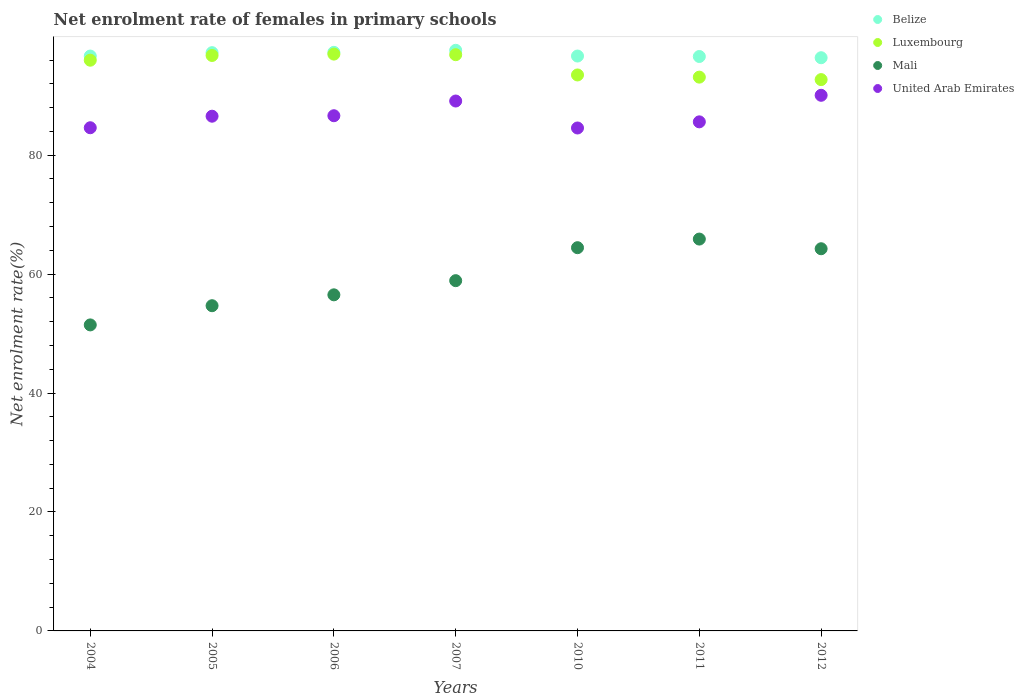How many different coloured dotlines are there?
Offer a very short reply. 4. Is the number of dotlines equal to the number of legend labels?
Your answer should be compact. Yes. What is the net enrolment rate of females in primary schools in Belize in 2006?
Your answer should be very brief. 97.29. Across all years, what is the maximum net enrolment rate of females in primary schools in Luxembourg?
Your response must be concise. 97. Across all years, what is the minimum net enrolment rate of females in primary schools in Luxembourg?
Make the answer very short. 92.71. In which year was the net enrolment rate of females in primary schools in Belize minimum?
Make the answer very short. 2012. What is the total net enrolment rate of females in primary schools in United Arab Emirates in the graph?
Your answer should be very brief. 607.16. What is the difference between the net enrolment rate of females in primary schools in Mali in 2004 and that in 2007?
Keep it short and to the point. -7.44. What is the difference between the net enrolment rate of females in primary schools in Luxembourg in 2012 and the net enrolment rate of females in primary schools in Belize in 2007?
Make the answer very short. -4.93. What is the average net enrolment rate of females in primary schools in Belize per year?
Your answer should be compact. 96.93. In the year 2007, what is the difference between the net enrolment rate of females in primary schools in Belize and net enrolment rate of females in primary schools in United Arab Emirates?
Your response must be concise. 8.53. In how many years, is the net enrolment rate of females in primary schools in Belize greater than 40 %?
Provide a short and direct response. 7. What is the ratio of the net enrolment rate of females in primary schools in Belize in 2006 to that in 2010?
Provide a succinct answer. 1.01. Is the net enrolment rate of females in primary schools in Belize in 2010 less than that in 2011?
Offer a very short reply. No. Is the difference between the net enrolment rate of females in primary schools in Belize in 2010 and 2011 greater than the difference between the net enrolment rate of females in primary schools in United Arab Emirates in 2010 and 2011?
Provide a succinct answer. Yes. What is the difference between the highest and the second highest net enrolment rate of females in primary schools in Mali?
Your response must be concise. 1.45. What is the difference between the highest and the lowest net enrolment rate of females in primary schools in Belize?
Offer a terse response. 1.25. Is it the case that in every year, the sum of the net enrolment rate of females in primary schools in Mali and net enrolment rate of females in primary schools in Belize  is greater than the sum of net enrolment rate of females in primary schools in United Arab Emirates and net enrolment rate of females in primary schools in Luxembourg?
Offer a very short reply. No. Is it the case that in every year, the sum of the net enrolment rate of females in primary schools in Mali and net enrolment rate of females in primary schools in Belize  is greater than the net enrolment rate of females in primary schools in Luxembourg?
Your answer should be very brief. Yes. Does the net enrolment rate of females in primary schools in Mali monotonically increase over the years?
Your answer should be compact. No. How many dotlines are there?
Provide a short and direct response. 4. How many years are there in the graph?
Ensure brevity in your answer.  7. What is the difference between two consecutive major ticks on the Y-axis?
Provide a succinct answer. 20. Does the graph contain any zero values?
Offer a terse response. No. How many legend labels are there?
Make the answer very short. 4. What is the title of the graph?
Your response must be concise. Net enrolment rate of females in primary schools. What is the label or title of the Y-axis?
Offer a very short reply. Net enrolment rate(%). What is the Net enrolment rate(%) of Belize in 2004?
Your answer should be very brief. 96.67. What is the Net enrolment rate(%) of Luxembourg in 2004?
Your answer should be very brief. 95.97. What is the Net enrolment rate(%) of Mali in 2004?
Provide a short and direct response. 51.46. What is the Net enrolment rate(%) of United Arab Emirates in 2004?
Your answer should be compact. 84.61. What is the Net enrolment rate(%) in Belize in 2005?
Your response must be concise. 97.24. What is the Net enrolment rate(%) of Luxembourg in 2005?
Your response must be concise. 96.77. What is the Net enrolment rate(%) of Mali in 2005?
Your answer should be very brief. 54.69. What is the Net enrolment rate(%) of United Arab Emirates in 2005?
Give a very brief answer. 86.55. What is the Net enrolment rate(%) of Belize in 2006?
Ensure brevity in your answer.  97.29. What is the Net enrolment rate(%) of Luxembourg in 2006?
Your answer should be very brief. 97. What is the Net enrolment rate(%) of Mali in 2006?
Offer a very short reply. 56.52. What is the Net enrolment rate(%) in United Arab Emirates in 2006?
Keep it short and to the point. 86.63. What is the Net enrolment rate(%) of Belize in 2007?
Offer a terse response. 97.64. What is the Net enrolment rate(%) in Luxembourg in 2007?
Ensure brevity in your answer.  96.9. What is the Net enrolment rate(%) of Mali in 2007?
Provide a short and direct response. 58.9. What is the Net enrolment rate(%) of United Arab Emirates in 2007?
Keep it short and to the point. 89.11. What is the Net enrolment rate(%) in Belize in 2010?
Your response must be concise. 96.67. What is the Net enrolment rate(%) of Luxembourg in 2010?
Give a very brief answer. 93.49. What is the Net enrolment rate(%) in Mali in 2010?
Keep it short and to the point. 64.44. What is the Net enrolment rate(%) of United Arab Emirates in 2010?
Make the answer very short. 84.57. What is the Net enrolment rate(%) of Belize in 2011?
Offer a terse response. 96.59. What is the Net enrolment rate(%) in Luxembourg in 2011?
Your response must be concise. 93.12. What is the Net enrolment rate(%) of Mali in 2011?
Your answer should be compact. 65.89. What is the Net enrolment rate(%) in United Arab Emirates in 2011?
Offer a terse response. 85.6. What is the Net enrolment rate(%) of Belize in 2012?
Ensure brevity in your answer.  96.39. What is the Net enrolment rate(%) in Luxembourg in 2012?
Ensure brevity in your answer.  92.71. What is the Net enrolment rate(%) in Mali in 2012?
Your response must be concise. 64.27. What is the Net enrolment rate(%) of United Arab Emirates in 2012?
Keep it short and to the point. 90.07. Across all years, what is the maximum Net enrolment rate(%) of Belize?
Ensure brevity in your answer.  97.64. Across all years, what is the maximum Net enrolment rate(%) of Luxembourg?
Your answer should be very brief. 97. Across all years, what is the maximum Net enrolment rate(%) in Mali?
Make the answer very short. 65.89. Across all years, what is the maximum Net enrolment rate(%) in United Arab Emirates?
Give a very brief answer. 90.07. Across all years, what is the minimum Net enrolment rate(%) of Belize?
Offer a terse response. 96.39. Across all years, what is the minimum Net enrolment rate(%) of Luxembourg?
Your answer should be very brief. 92.71. Across all years, what is the minimum Net enrolment rate(%) in Mali?
Make the answer very short. 51.46. Across all years, what is the minimum Net enrolment rate(%) in United Arab Emirates?
Provide a short and direct response. 84.57. What is the total Net enrolment rate(%) in Belize in the graph?
Your answer should be very brief. 678.49. What is the total Net enrolment rate(%) of Luxembourg in the graph?
Your answer should be very brief. 665.96. What is the total Net enrolment rate(%) of Mali in the graph?
Keep it short and to the point. 416.17. What is the total Net enrolment rate(%) in United Arab Emirates in the graph?
Your answer should be compact. 607.16. What is the difference between the Net enrolment rate(%) of Belize in 2004 and that in 2005?
Keep it short and to the point. -0.57. What is the difference between the Net enrolment rate(%) of Luxembourg in 2004 and that in 2005?
Keep it short and to the point. -0.79. What is the difference between the Net enrolment rate(%) in Mali in 2004 and that in 2005?
Ensure brevity in your answer.  -3.23. What is the difference between the Net enrolment rate(%) in United Arab Emirates in 2004 and that in 2005?
Keep it short and to the point. -1.94. What is the difference between the Net enrolment rate(%) of Belize in 2004 and that in 2006?
Ensure brevity in your answer.  -0.62. What is the difference between the Net enrolment rate(%) in Luxembourg in 2004 and that in 2006?
Ensure brevity in your answer.  -1.02. What is the difference between the Net enrolment rate(%) in Mali in 2004 and that in 2006?
Keep it short and to the point. -5.06. What is the difference between the Net enrolment rate(%) of United Arab Emirates in 2004 and that in 2006?
Your response must be concise. -2.02. What is the difference between the Net enrolment rate(%) in Belize in 2004 and that in 2007?
Make the answer very short. -0.97. What is the difference between the Net enrolment rate(%) of Luxembourg in 2004 and that in 2007?
Offer a very short reply. -0.92. What is the difference between the Net enrolment rate(%) of Mali in 2004 and that in 2007?
Ensure brevity in your answer.  -7.44. What is the difference between the Net enrolment rate(%) in United Arab Emirates in 2004 and that in 2007?
Your answer should be compact. -4.49. What is the difference between the Net enrolment rate(%) in Belize in 2004 and that in 2010?
Offer a very short reply. -0. What is the difference between the Net enrolment rate(%) in Luxembourg in 2004 and that in 2010?
Give a very brief answer. 2.48. What is the difference between the Net enrolment rate(%) in Mali in 2004 and that in 2010?
Your answer should be compact. -12.99. What is the difference between the Net enrolment rate(%) in United Arab Emirates in 2004 and that in 2010?
Provide a succinct answer. 0.04. What is the difference between the Net enrolment rate(%) of Belize in 2004 and that in 2011?
Provide a short and direct response. 0.07. What is the difference between the Net enrolment rate(%) of Luxembourg in 2004 and that in 2011?
Provide a succinct answer. 2.85. What is the difference between the Net enrolment rate(%) of Mali in 2004 and that in 2011?
Offer a terse response. -14.43. What is the difference between the Net enrolment rate(%) of United Arab Emirates in 2004 and that in 2011?
Provide a succinct answer. -0.99. What is the difference between the Net enrolment rate(%) of Belize in 2004 and that in 2012?
Make the answer very short. 0.28. What is the difference between the Net enrolment rate(%) of Luxembourg in 2004 and that in 2012?
Offer a very short reply. 3.26. What is the difference between the Net enrolment rate(%) of Mali in 2004 and that in 2012?
Ensure brevity in your answer.  -12.81. What is the difference between the Net enrolment rate(%) in United Arab Emirates in 2004 and that in 2012?
Give a very brief answer. -5.46. What is the difference between the Net enrolment rate(%) in Belize in 2005 and that in 2006?
Provide a succinct answer. -0.05. What is the difference between the Net enrolment rate(%) in Luxembourg in 2005 and that in 2006?
Keep it short and to the point. -0.23. What is the difference between the Net enrolment rate(%) in Mali in 2005 and that in 2006?
Your answer should be compact. -1.83. What is the difference between the Net enrolment rate(%) in United Arab Emirates in 2005 and that in 2006?
Your answer should be compact. -0.08. What is the difference between the Net enrolment rate(%) in Belize in 2005 and that in 2007?
Keep it short and to the point. -0.4. What is the difference between the Net enrolment rate(%) in Luxembourg in 2005 and that in 2007?
Provide a short and direct response. -0.13. What is the difference between the Net enrolment rate(%) in Mali in 2005 and that in 2007?
Keep it short and to the point. -4.21. What is the difference between the Net enrolment rate(%) of United Arab Emirates in 2005 and that in 2007?
Give a very brief answer. -2.55. What is the difference between the Net enrolment rate(%) of Belize in 2005 and that in 2010?
Your answer should be compact. 0.57. What is the difference between the Net enrolment rate(%) of Luxembourg in 2005 and that in 2010?
Ensure brevity in your answer.  3.28. What is the difference between the Net enrolment rate(%) of Mali in 2005 and that in 2010?
Make the answer very short. -9.76. What is the difference between the Net enrolment rate(%) in United Arab Emirates in 2005 and that in 2010?
Provide a succinct answer. 1.98. What is the difference between the Net enrolment rate(%) in Belize in 2005 and that in 2011?
Give a very brief answer. 0.65. What is the difference between the Net enrolment rate(%) of Luxembourg in 2005 and that in 2011?
Make the answer very short. 3.64. What is the difference between the Net enrolment rate(%) in Mali in 2005 and that in 2011?
Keep it short and to the point. -11.21. What is the difference between the Net enrolment rate(%) of United Arab Emirates in 2005 and that in 2011?
Your response must be concise. 0.95. What is the difference between the Net enrolment rate(%) of Belize in 2005 and that in 2012?
Give a very brief answer. 0.85. What is the difference between the Net enrolment rate(%) in Luxembourg in 2005 and that in 2012?
Offer a terse response. 4.06. What is the difference between the Net enrolment rate(%) of Mali in 2005 and that in 2012?
Your answer should be compact. -9.58. What is the difference between the Net enrolment rate(%) of United Arab Emirates in 2005 and that in 2012?
Your answer should be compact. -3.52. What is the difference between the Net enrolment rate(%) in Belize in 2006 and that in 2007?
Your response must be concise. -0.34. What is the difference between the Net enrolment rate(%) in Luxembourg in 2006 and that in 2007?
Offer a very short reply. 0.1. What is the difference between the Net enrolment rate(%) in Mali in 2006 and that in 2007?
Give a very brief answer. -2.38. What is the difference between the Net enrolment rate(%) in United Arab Emirates in 2006 and that in 2007?
Provide a short and direct response. -2.47. What is the difference between the Net enrolment rate(%) of Belize in 2006 and that in 2010?
Offer a terse response. 0.62. What is the difference between the Net enrolment rate(%) of Luxembourg in 2006 and that in 2010?
Your answer should be compact. 3.51. What is the difference between the Net enrolment rate(%) in Mali in 2006 and that in 2010?
Provide a short and direct response. -7.93. What is the difference between the Net enrolment rate(%) of United Arab Emirates in 2006 and that in 2010?
Make the answer very short. 2.06. What is the difference between the Net enrolment rate(%) of Belize in 2006 and that in 2011?
Make the answer very short. 0.7. What is the difference between the Net enrolment rate(%) of Luxembourg in 2006 and that in 2011?
Your answer should be very brief. 3.87. What is the difference between the Net enrolment rate(%) of Mali in 2006 and that in 2011?
Ensure brevity in your answer.  -9.38. What is the difference between the Net enrolment rate(%) of United Arab Emirates in 2006 and that in 2011?
Provide a short and direct response. 1.03. What is the difference between the Net enrolment rate(%) of Belize in 2006 and that in 2012?
Provide a short and direct response. 0.9. What is the difference between the Net enrolment rate(%) of Luxembourg in 2006 and that in 2012?
Your answer should be compact. 4.29. What is the difference between the Net enrolment rate(%) in Mali in 2006 and that in 2012?
Your response must be concise. -7.75. What is the difference between the Net enrolment rate(%) of United Arab Emirates in 2006 and that in 2012?
Make the answer very short. -3.44. What is the difference between the Net enrolment rate(%) of Belize in 2007 and that in 2010?
Your answer should be very brief. 0.96. What is the difference between the Net enrolment rate(%) in Luxembourg in 2007 and that in 2010?
Keep it short and to the point. 3.41. What is the difference between the Net enrolment rate(%) in Mali in 2007 and that in 2010?
Your answer should be very brief. -5.55. What is the difference between the Net enrolment rate(%) of United Arab Emirates in 2007 and that in 2010?
Keep it short and to the point. 4.54. What is the difference between the Net enrolment rate(%) in Belize in 2007 and that in 2011?
Provide a short and direct response. 1.04. What is the difference between the Net enrolment rate(%) of Luxembourg in 2007 and that in 2011?
Your answer should be very brief. 3.77. What is the difference between the Net enrolment rate(%) of Mali in 2007 and that in 2011?
Provide a succinct answer. -6.99. What is the difference between the Net enrolment rate(%) in United Arab Emirates in 2007 and that in 2011?
Offer a terse response. 3.5. What is the difference between the Net enrolment rate(%) in Belize in 2007 and that in 2012?
Your answer should be very brief. 1.25. What is the difference between the Net enrolment rate(%) in Luxembourg in 2007 and that in 2012?
Offer a terse response. 4.19. What is the difference between the Net enrolment rate(%) of Mali in 2007 and that in 2012?
Your response must be concise. -5.37. What is the difference between the Net enrolment rate(%) in United Arab Emirates in 2007 and that in 2012?
Ensure brevity in your answer.  -0.96. What is the difference between the Net enrolment rate(%) in Belize in 2010 and that in 2011?
Keep it short and to the point. 0.08. What is the difference between the Net enrolment rate(%) in Luxembourg in 2010 and that in 2011?
Keep it short and to the point. 0.37. What is the difference between the Net enrolment rate(%) of Mali in 2010 and that in 2011?
Keep it short and to the point. -1.45. What is the difference between the Net enrolment rate(%) in United Arab Emirates in 2010 and that in 2011?
Provide a short and direct response. -1.03. What is the difference between the Net enrolment rate(%) in Belize in 2010 and that in 2012?
Give a very brief answer. 0.28. What is the difference between the Net enrolment rate(%) of Luxembourg in 2010 and that in 2012?
Your response must be concise. 0.78. What is the difference between the Net enrolment rate(%) of Mali in 2010 and that in 2012?
Your answer should be compact. 0.18. What is the difference between the Net enrolment rate(%) in United Arab Emirates in 2010 and that in 2012?
Make the answer very short. -5.5. What is the difference between the Net enrolment rate(%) in Belize in 2011 and that in 2012?
Make the answer very short. 0.21. What is the difference between the Net enrolment rate(%) in Luxembourg in 2011 and that in 2012?
Give a very brief answer. 0.41. What is the difference between the Net enrolment rate(%) in Mali in 2011 and that in 2012?
Your answer should be compact. 1.63. What is the difference between the Net enrolment rate(%) in United Arab Emirates in 2011 and that in 2012?
Give a very brief answer. -4.47. What is the difference between the Net enrolment rate(%) in Belize in 2004 and the Net enrolment rate(%) in Luxembourg in 2005?
Provide a succinct answer. -0.1. What is the difference between the Net enrolment rate(%) of Belize in 2004 and the Net enrolment rate(%) of Mali in 2005?
Ensure brevity in your answer.  41.98. What is the difference between the Net enrolment rate(%) of Belize in 2004 and the Net enrolment rate(%) of United Arab Emirates in 2005?
Offer a very short reply. 10.11. What is the difference between the Net enrolment rate(%) in Luxembourg in 2004 and the Net enrolment rate(%) in Mali in 2005?
Your response must be concise. 41.28. What is the difference between the Net enrolment rate(%) of Luxembourg in 2004 and the Net enrolment rate(%) of United Arab Emirates in 2005?
Keep it short and to the point. 9.42. What is the difference between the Net enrolment rate(%) of Mali in 2004 and the Net enrolment rate(%) of United Arab Emirates in 2005?
Your answer should be compact. -35.1. What is the difference between the Net enrolment rate(%) of Belize in 2004 and the Net enrolment rate(%) of Luxembourg in 2006?
Offer a very short reply. -0.33. What is the difference between the Net enrolment rate(%) of Belize in 2004 and the Net enrolment rate(%) of Mali in 2006?
Keep it short and to the point. 40.15. What is the difference between the Net enrolment rate(%) of Belize in 2004 and the Net enrolment rate(%) of United Arab Emirates in 2006?
Your answer should be very brief. 10.03. What is the difference between the Net enrolment rate(%) in Luxembourg in 2004 and the Net enrolment rate(%) in Mali in 2006?
Make the answer very short. 39.46. What is the difference between the Net enrolment rate(%) in Luxembourg in 2004 and the Net enrolment rate(%) in United Arab Emirates in 2006?
Offer a very short reply. 9.34. What is the difference between the Net enrolment rate(%) in Mali in 2004 and the Net enrolment rate(%) in United Arab Emirates in 2006?
Make the answer very short. -35.18. What is the difference between the Net enrolment rate(%) of Belize in 2004 and the Net enrolment rate(%) of Luxembourg in 2007?
Your response must be concise. -0.23. What is the difference between the Net enrolment rate(%) in Belize in 2004 and the Net enrolment rate(%) in Mali in 2007?
Offer a very short reply. 37.77. What is the difference between the Net enrolment rate(%) in Belize in 2004 and the Net enrolment rate(%) in United Arab Emirates in 2007?
Ensure brevity in your answer.  7.56. What is the difference between the Net enrolment rate(%) of Luxembourg in 2004 and the Net enrolment rate(%) of Mali in 2007?
Your response must be concise. 37.07. What is the difference between the Net enrolment rate(%) of Luxembourg in 2004 and the Net enrolment rate(%) of United Arab Emirates in 2007?
Keep it short and to the point. 6.86. What is the difference between the Net enrolment rate(%) in Mali in 2004 and the Net enrolment rate(%) in United Arab Emirates in 2007?
Your response must be concise. -37.65. What is the difference between the Net enrolment rate(%) of Belize in 2004 and the Net enrolment rate(%) of Luxembourg in 2010?
Ensure brevity in your answer.  3.18. What is the difference between the Net enrolment rate(%) of Belize in 2004 and the Net enrolment rate(%) of Mali in 2010?
Your answer should be compact. 32.22. What is the difference between the Net enrolment rate(%) of Belize in 2004 and the Net enrolment rate(%) of United Arab Emirates in 2010?
Provide a succinct answer. 12.09. What is the difference between the Net enrolment rate(%) of Luxembourg in 2004 and the Net enrolment rate(%) of Mali in 2010?
Your answer should be compact. 31.53. What is the difference between the Net enrolment rate(%) of Luxembourg in 2004 and the Net enrolment rate(%) of United Arab Emirates in 2010?
Provide a succinct answer. 11.4. What is the difference between the Net enrolment rate(%) of Mali in 2004 and the Net enrolment rate(%) of United Arab Emirates in 2010?
Offer a very short reply. -33.11. What is the difference between the Net enrolment rate(%) of Belize in 2004 and the Net enrolment rate(%) of Luxembourg in 2011?
Provide a short and direct response. 3.54. What is the difference between the Net enrolment rate(%) in Belize in 2004 and the Net enrolment rate(%) in Mali in 2011?
Offer a very short reply. 30.77. What is the difference between the Net enrolment rate(%) in Belize in 2004 and the Net enrolment rate(%) in United Arab Emirates in 2011?
Your response must be concise. 11.06. What is the difference between the Net enrolment rate(%) in Luxembourg in 2004 and the Net enrolment rate(%) in Mali in 2011?
Give a very brief answer. 30.08. What is the difference between the Net enrolment rate(%) in Luxembourg in 2004 and the Net enrolment rate(%) in United Arab Emirates in 2011?
Your response must be concise. 10.37. What is the difference between the Net enrolment rate(%) in Mali in 2004 and the Net enrolment rate(%) in United Arab Emirates in 2011?
Provide a succinct answer. -34.15. What is the difference between the Net enrolment rate(%) in Belize in 2004 and the Net enrolment rate(%) in Luxembourg in 2012?
Give a very brief answer. 3.96. What is the difference between the Net enrolment rate(%) of Belize in 2004 and the Net enrolment rate(%) of Mali in 2012?
Offer a very short reply. 32.4. What is the difference between the Net enrolment rate(%) in Belize in 2004 and the Net enrolment rate(%) in United Arab Emirates in 2012?
Keep it short and to the point. 6.6. What is the difference between the Net enrolment rate(%) in Luxembourg in 2004 and the Net enrolment rate(%) in Mali in 2012?
Provide a succinct answer. 31.71. What is the difference between the Net enrolment rate(%) in Luxembourg in 2004 and the Net enrolment rate(%) in United Arab Emirates in 2012?
Give a very brief answer. 5.9. What is the difference between the Net enrolment rate(%) in Mali in 2004 and the Net enrolment rate(%) in United Arab Emirates in 2012?
Provide a short and direct response. -38.61. What is the difference between the Net enrolment rate(%) of Belize in 2005 and the Net enrolment rate(%) of Luxembourg in 2006?
Provide a succinct answer. 0.24. What is the difference between the Net enrolment rate(%) in Belize in 2005 and the Net enrolment rate(%) in Mali in 2006?
Provide a short and direct response. 40.72. What is the difference between the Net enrolment rate(%) in Belize in 2005 and the Net enrolment rate(%) in United Arab Emirates in 2006?
Provide a short and direct response. 10.6. What is the difference between the Net enrolment rate(%) in Luxembourg in 2005 and the Net enrolment rate(%) in Mali in 2006?
Your answer should be compact. 40.25. What is the difference between the Net enrolment rate(%) of Luxembourg in 2005 and the Net enrolment rate(%) of United Arab Emirates in 2006?
Give a very brief answer. 10.13. What is the difference between the Net enrolment rate(%) in Mali in 2005 and the Net enrolment rate(%) in United Arab Emirates in 2006?
Your answer should be compact. -31.95. What is the difference between the Net enrolment rate(%) of Belize in 2005 and the Net enrolment rate(%) of Luxembourg in 2007?
Provide a short and direct response. 0.34. What is the difference between the Net enrolment rate(%) of Belize in 2005 and the Net enrolment rate(%) of Mali in 2007?
Your answer should be compact. 38.34. What is the difference between the Net enrolment rate(%) in Belize in 2005 and the Net enrolment rate(%) in United Arab Emirates in 2007?
Your answer should be very brief. 8.13. What is the difference between the Net enrolment rate(%) of Luxembourg in 2005 and the Net enrolment rate(%) of Mali in 2007?
Offer a terse response. 37.87. What is the difference between the Net enrolment rate(%) of Luxembourg in 2005 and the Net enrolment rate(%) of United Arab Emirates in 2007?
Provide a short and direct response. 7.66. What is the difference between the Net enrolment rate(%) of Mali in 2005 and the Net enrolment rate(%) of United Arab Emirates in 2007?
Ensure brevity in your answer.  -34.42. What is the difference between the Net enrolment rate(%) of Belize in 2005 and the Net enrolment rate(%) of Luxembourg in 2010?
Provide a short and direct response. 3.75. What is the difference between the Net enrolment rate(%) of Belize in 2005 and the Net enrolment rate(%) of Mali in 2010?
Make the answer very short. 32.79. What is the difference between the Net enrolment rate(%) of Belize in 2005 and the Net enrolment rate(%) of United Arab Emirates in 2010?
Your answer should be compact. 12.67. What is the difference between the Net enrolment rate(%) of Luxembourg in 2005 and the Net enrolment rate(%) of Mali in 2010?
Offer a terse response. 32.32. What is the difference between the Net enrolment rate(%) of Luxembourg in 2005 and the Net enrolment rate(%) of United Arab Emirates in 2010?
Keep it short and to the point. 12.19. What is the difference between the Net enrolment rate(%) of Mali in 2005 and the Net enrolment rate(%) of United Arab Emirates in 2010?
Offer a terse response. -29.88. What is the difference between the Net enrolment rate(%) of Belize in 2005 and the Net enrolment rate(%) of Luxembourg in 2011?
Make the answer very short. 4.11. What is the difference between the Net enrolment rate(%) in Belize in 2005 and the Net enrolment rate(%) in Mali in 2011?
Give a very brief answer. 31.35. What is the difference between the Net enrolment rate(%) in Belize in 2005 and the Net enrolment rate(%) in United Arab Emirates in 2011?
Provide a short and direct response. 11.63. What is the difference between the Net enrolment rate(%) in Luxembourg in 2005 and the Net enrolment rate(%) in Mali in 2011?
Your response must be concise. 30.87. What is the difference between the Net enrolment rate(%) in Luxembourg in 2005 and the Net enrolment rate(%) in United Arab Emirates in 2011?
Your answer should be compact. 11.16. What is the difference between the Net enrolment rate(%) in Mali in 2005 and the Net enrolment rate(%) in United Arab Emirates in 2011?
Ensure brevity in your answer.  -30.92. What is the difference between the Net enrolment rate(%) of Belize in 2005 and the Net enrolment rate(%) of Luxembourg in 2012?
Your response must be concise. 4.53. What is the difference between the Net enrolment rate(%) of Belize in 2005 and the Net enrolment rate(%) of Mali in 2012?
Offer a very short reply. 32.97. What is the difference between the Net enrolment rate(%) of Belize in 2005 and the Net enrolment rate(%) of United Arab Emirates in 2012?
Offer a very short reply. 7.17. What is the difference between the Net enrolment rate(%) in Luxembourg in 2005 and the Net enrolment rate(%) in Mali in 2012?
Ensure brevity in your answer.  32.5. What is the difference between the Net enrolment rate(%) of Luxembourg in 2005 and the Net enrolment rate(%) of United Arab Emirates in 2012?
Give a very brief answer. 6.7. What is the difference between the Net enrolment rate(%) in Mali in 2005 and the Net enrolment rate(%) in United Arab Emirates in 2012?
Offer a very short reply. -35.38. What is the difference between the Net enrolment rate(%) of Belize in 2006 and the Net enrolment rate(%) of Luxembourg in 2007?
Give a very brief answer. 0.39. What is the difference between the Net enrolment rate(%) in Belize in 2006 and the Net enrolment rate(%) in Mali in 2007?
Provide a short and direct response. 38.39. What is the difference between the Net enrolment rate(%) in Belize in 2006 and the Net enrolment rate(%) in United Arab Emirates in 2007?
Give a very brief answer. 8.18. What is the difference between the Net enrolment rate(%) in Luxembourg in 2006 and the Net enrolment rate(%) in Mali in 2007?
Make the answer very short. 38.1. What is the difference between the Net enrolment rate(%) in Luxembourg in 2006 and the Net enrolment rate(%) in United Arab Emirates in 2007?
Offer a terse response. 7.89. What is the difference between the Net enrolment rate(%) of Mali in 2006 and the Net enrolment rate(%) of United Arab Emirates in 2007?
Ensure brevity in your answer.  -32.59. What is the difference between the Net enrolment rate(%) in Belize in 2006 and the Net enrolment rate(%) in Luxembourg in 2010?
Offer a terse response. 3.8. What is the difference between the Net enrolment rate(%) in Belize in 2006 and the Net enrolment rate(%) in Mali in 2010?
Offer a terse response. 32.85. What is the difference between the Net enrolment rate(%) in Belize in 2006 and the Net enrolment rate(%) in United Arab Emirates in 2010?
Offer a very short reply. 12.72. What is the difference between the Net enrolment rate(%) of Luxembourg in 2006 and the Net enrolment rate(%) of Mali in 2010?
Provide a succinct answer. 32.55. What is the difference between the Net enrolment rate(%) of Luxembourg in 2006 and the Net enrolment rate(%) of United Arab Emirates in 2010?
Your answer should be compact. 12.42. What is the difference between the Net enrolment rate(%) of Mali in 2006 and the Net enrolment rate(%) of United Arab Emirates in 2010?
Ensure brevity in your answer.  -28.06. What is the difference between the Net enrolment rate(%) in Belize in 2006 and the Net enrolment rate(%) in Luxembourg in 2011?
Provide a succinct answer. 4.17. What is the difference between the Net enrolment rate(%) in Belize in 2006 and the Net enrolment rate(%) in Mali in 2011?
Make the answer very short. 31.4. What is the difference between the Net enrolment rate(%) in Belize in 2006 and the Net enrolment rate(%) in United Arab Emirates in 2011?
Offer a very short reply. 11.69. What is the difference between the Net enrolment rate(%) in Luxembourg in 2006 and the Net enrolment rate(%) in Mali in 2011?
Keep it short and to the point. 31.1. What is the difference between the Net enrolment rate(%) in Luxembourg in 2006 and the Net enrolment rate(%) in United Arab Emirates in 2011?
Your response must be concise. 11.39. What is the difference between the Net enrolment rate(%) in Mali in 2006 and the Net enrolment rate(%) in United Arab Emirates in 2011?
Your answer should be very brief. -29.09. What is the difference between the Net enrolment rate(%) of Belize in 2006 and the Net enrolment rate(%) of Luxembourg in 2012?
Make the answer very short. 4.58. What is the difference between the Net enrolment rate(%) in Belize in 2006 and the Net enrolment rate(%) in Mali in 2012?
Provide a short and direct response. 33.02. What is the difference between the Net enrolment rate(%) of Belize in 2006 and the Net enrolment rate(%) of United Arab Emirates in 2012?
Make the answer very short. 7.22. What is the difference between the Net enrolment rate(%) in Luxembourg in 2006 and the Net enrolment rate(%) in Mali in 2012?
Your answer should be compact. 32.73. What is the difference between the Net enrolment rate(%) of Luxembourg in 2006 and the Net enrolment rate(%) of United Arab Emirates in 2012?
Give a very brief answer. 6.93. What is the difference between the Net enrolment rate(%) of Mali in 2006 and the Net enrolment rate(%) of United Arab Emirates in 2012?
Offer a very short reply. -33.55. What is the difference between the Net enrolment rate(%) of Belize in 2007 and the Net enrolment rate(%) of Luxembourg in 2010?
Provide a succinct answer. 4.15. What is the difference between the Net enrolment rate(%) of Belize in 2007 and the Net enrolment rate(%) of Mali in 2010?
Ensure brevity in your answer.  33.19. What is the difference between the Net enrolment rate(%) in Belize in 2007 and the Net enrolment rate(%) in United Arab Emirates in 2010?
Provide a short and direct response. 13.06. What is the difference between the Net enrolment rate(%) of Luxembourg in 2007 and the Net enrolment rate(%) of Mali in 2010?
Ensure brevity in your answer.  32.45. What is the difference between the Net enrolment rate(%) in Luxembourg in 2007 and the Net enrolment rate(%) in United Arab Emirates in 2010?
Offer a very short reply. 12.32. What is the difference between the Net enrolment rate(%) in Mali in 2007 and the Net enrolment rate(%) in United Arab Emirates in 2010?
Keep it short and to the point. -25.67. What is the difference between the Net enrolment rate(%) in Belize in 2007 and the Net enrolment rate(%) in Luxembourg in 2011?
Provide a short and direct response. 4.51. What is the difference between the Net enrolment rate(%) in Belize in 2007 and the Net enrolment rate(%) in Mali in 2011?
Provide a succinct answer. 31.74. What is the difference between the Net enrolment rate(%) of Belize in 2007 and the Net enrolment rate(%) of United Arab Emirates in 2011?
Provide a short and direct response. 12.03. What is the difference between the Net enrolment rate(%) in Luxembourg in 2007 and the Net enrolment rate(%) in Mali in 2011?
Your answer should be compact. 31. What is the difference between the Net enrolment rate(%) in Luxembourg in 2007 and the Net enrolment rate(%) in United Arab Emirates in 2011?
Provide a short and direct response. 11.29. What is the difference between the Net enrolment rate(%) of Mali in 2007 and the Net enrolment rate(%) of United Arab Emirates in 2011?
Offer a very short reply. -26.71. What is the difference between the Net enrolment rate(%) of Belize in 2007 and the Net enrolment rate(%) of Luxembourg in 2012?
Offer a terse response. 4.93. What is the difference between the Net enrolment rate(%) in Belize in 2007 and the Net enrolment rate(%) in Mali in 2012?
Offer a very short reply. 33.37. What is the difference between the Net enrolment rate(%) of Belize in 2007 and the Net enrolment rate(%) of United Arab Emirates in 2012?
Ensure brevity in your answer.  7.57. What is the difference between the Net enrolment rate(%) in Luxembourg in 2007 and the Net enrolment rate(%) in Mali in 2012?
Offer a very short reply. 32.63. What is the difference between the Net enrolment rate(%) in Luxembourg in 2007 and the Net enrolment rate(%) in United Arab Emirates in 2012?
Ensure brevity in your answer.  6.83. What is the difference between the Net enrolment rate(%) in Mali in 2007 and the Net enrolment rate(%) in United Arab Emirates in 2012?
Ensure brevity in your answer.  -31.17. What is the difference between the Net enrolment rate(%) in Belize in 2010 and the Net enrolment rate(%) in Luxembourg in 2011?
Provide a succinct answer. 3.55. What is the difference between the Net enrolment rate(%) in Belize in 2010 and the Net enrolment rate(%) in Mali in 2011?
Provide a short and direct response. 30.78. What is the difference between the Net enrolment rate(%) of Belize in 2010 and the Net enrolment rate(%) of United Arab Emirates in 2011?
Keep it short and to the point. 11.07. What is the difference between the Net enrolment rate(%) in Luxembourg in 2010 and the Net enrolment rate(%) in Mali in 2011?
Provide a succinct answer. 27.6. What is the difference between the Net enrolment rate(%) in Luxembourg in 2010 and the Net enrolment rate(%) in United Arab Emirates in 2011?
Give a very brief answer. 7.89. What is the difference between the Net enrolment rate(%) in Mali in 2010 and the Net enrolment rate(%) in United Arab Emirates in 2011?
Make the answer very short. -21.16. What is the difference between the Net enrolment rate(%) of Belize in 2010 and the Net enrolment rate(%) of Luxembourg in 2012?
Make the answer very short. 3.96. What is the difference between the Net enrolment rate(%) of Belize in 2010 and the Net enrolment rate(%) of Mali in 2012?
Ensure brevity in your answer.  32.4. What is the difference between the Net enrolment rate(%) in Belize in 2010 and the Net enrolment rate(%) in United Arab Emirates in 2012?
Offer a very short reply. 6.6. What is the difference between the Net enrolment rate(%) of Luxembourg in 2010 and the Net enrolment rate(%) of Mali in 2012?
Make the answer very short. 29.22. What is the difference between the Net enrolment rate(%) of Luxembourg in 2010 and the Net enrolment rate(%) of United Arab Emirates in 2012?
Keep it short and to the point. 3.42. What is the difference between the Net enrolment rate(%) in Mali in 2010 and the Net enrolment rate(%) in United Arab Emirates in 2012?
Make the answer very short. -25.63. What is the difference between the Net enrolment rate(%) in Belize in 2011 and the Net enrolment rate(%) in Luxembourg in 2012?
Make the answer very short. 3.88. What is the difference between the Net enrolment rate(%) of Belize in 2011 and the Net enrolment rate(%) of Mali in 2012?
Provide a succinct answer. 32.33. What is the difference between the Net enrolment rate(%) in Belize in 2011 and the Net enrolment rate(%) in United Arab Emirates in 2012?
Offer a terse response. 6.52. What is the difference between the Net enrolment rate(%) in Luxembourg in 2011 and the Net enrolment rate(%) in Mali in 2012?
Make the answer very short. 28.86. What is the difference between the Net enrolment rate(%) of Luxembourg in 2011 and the Net enrolment rate(%) of United Arab Emirates in 2012?
Your response must be concise. 3.05. What is the difference between the Net enrolment rate(%) in Mali in 2011 and the Net enrolment rate(%) in United Arab Emirates in 2012?
Keep it short and to the point. -24.18. What is the average Net enrolment rate(%) in Belize per year?
Make the answer very short. 96.93. What is the average Net enrolment rate(%) in Luxembourg per year?
Keep it short and to the point. 95.14. What is the average Net enrolment rate(%) of Mali per year?
Make the answer very short. 59.45. What is the average Net enrolment rate(%) of United Arab Emirates per year?
Give a very brief answer. 86.74. In the year 2004, what is the difference between the Net enrolment rate(%) in Belize and Net enrolment rate(%) in Luxembourg?
Provide a succinct answer. 0.69. In the year 2004, what is the difference between the Net enrolment rate(%) in Belize and Net enrolment rate(%) in Mali?
Your answer should be very brief. 45.21. In the year 2004, what is the difference between the Net enrolment rate(%) in Belize and Net enrolment rate(%) in United Arab Emirates?
Your answer should be very brief. 12.05. In the year 2004, what is the difference between the Net enrolment rate(%) in Luxembourg and Net enrolment rate(%) in Mali?
Your response must be concise. 44.51. In the year 2004, what is the difference between the Net enrolment rate(%) in Luxembourg and Net enrolment rate(%) in United Arab Emirates?
Make the answer very short. 11.36. In the year 2004, what is the difference between the Net enrolment rate(%) in Mali and Net enrolment rate(%) in United Arab Emirates?
Give a very brief answer. -33.15. In the year 2005, what is the difference between the Net enrolment rate(%) in Belize and Net enrolment rate(%) in Luxembourg?
Make the answer very short. 0.47. In the year 2005, what is the difference between the Net enrolment rate(%) of Belize and Net enrolment rate(%) of Mali?
Ensure brevity in your answer.  42.55. In the year 2005, what is the difference between the Net enrolment rate(%) in Belize and Net enrolment rate(%) in United Arab Emirates?
Make the answer very short. 10.69. In the year 2005, what is the difference between the Net enrolment rate(%) of Luxembourg and Net enrolment rate(%) of Mali?
Your response must be concise. 42.08. In the year 2005, what is the difference between the Net enrolment rate(%) in Luxembourg and Net enrolment rate(%) in United Arab Emirates?
Offer a terse response. 10.21. In the year 2005, what is the difference between the Net enrolment rate(%) in Mali and Net enrolment rate(%) in United Arab Emirates?
Keep it short and to the point. -31.87. In the year 2006, what is the difference between the Net enrolment rate(%) of Belize and Net enrolment rate(%) of Luxembourg?
Your answer should be very brief. 0.29. In the year 2006, what is the difference between the Net enrolment rate(%) of Belize and Net enrolment rate(%) of Mali?
Offer a very short reply. 40.77. In the year 2006, what is the difference between the Net enrolment rate(%) in Belize and Net enrolment rate(%) in United Arab Emirates?
Offer a terse response. 10.66. In the year 2006, what is the difference between the Net enrolment rate(%) of Luxembourg and Net enrolment rate(%) of Mali?
Offer a very short reply. 40.48. In the year 2006, what is the difference between the Net enrolment rate(%) of Luxembourg and Net enrolment rate(%) of United Arab Emirates?
Your answer should be compact. 10.36. In the year 2006, what is the difference between the Net enrolment rate(%) in Mali and Net enrolment rate(%) in United Arab Emirates?
Offer a terse response. -30.12. In the year 2007, what is the difference between the Net enrolment rate(%) of Belize and Net enrolment rate(%) of Luxembourg?
Your response must be concise. 0.74. In the year 2007, what is the difference between the Net enrolment rate(%) in Belize and Net enrolment rate(%) in Mali?
Give a very brief answer. 38.74. In the year 2007, what is the difference between the Net enrolment rate(%) in Belize and Net enrolment rate(%) in United Arab Emirates?
Your answer should be very brief. 8.53. In the year 2007, what is the difference between the Net enrolment rate(%) in Luxembourg and Net enrolment rate(%) in Mali?
Provide a short and direct response. 38. In the year 2007, what is the difference between the Net enrolment rate(%) of Luxembourg and Net enrolment rate(%) of United Arab Emirates?
Ensure brevity in your answer.  7.79. In the year 2007, what is the difference between the Net enrolment rate(%) in Mali and Net enrolment rate(%) in United Arab Emirates?
Keep it short and to the point. -30.21. In the year 2010, what is the difference between the Net enrolment rate(%) of Belize and Net enrolment rate(%) of Luxembourg?
Offer a terse response. 3.18. In the year 2010, what is the difference between the Net enrolment rate(%) in Belize and Net enrolment rate(%) in Mali?
Provide a short and direct response. 32.23. In the year 2010, what is the difference between the Net enrolment rate(%) of Belize and Net enrolment rate(%) of United Arab Emirates?
Offer a very short reply. 12.1. In the year 2010, what is the difference between the Net enrolment rate(%) in Luxembourg and Net enrolment rate(%) in Mali?
Provide a short and direct response. 29.05. In the year 2010, what is the difference between the Net enrolment rate(%) of Luxembourg and Net enrolment rate(%) of United Arab Emirates?
Provide a succinct answer. 8.92. In the year 2010, what is the difference between the Net enrolment rate(%) of Mali and Net enrolment rate(%) of United Arab Emirates?
Give a very brief answer. -20.13. In the year 2011, what is the difference between the Net enrolment rate(%) in Belize and Net enrolment rate(%) in Luxembourg?
Make the answer very short. 3.47. In the year 2011, what is the difference between the Net enrolment rate(%) of Belize and Net enrolment rate(%) of Mali?
Your answer should be compact. 30.7. In the year 2011, what is the difference between the Net enrolment rate(%) of Belize and Net enrolment rate(%) of United Arab Emirates?
Your response must be concise. 10.99. In the year 2011, what is the difference between the Net enrolment rate(%) in Luxembourg and Net enrolment rate(%) in Mali?
Make the answer very short. 27.23. In the year 2011, what is the difference between the Net enrolment rate(%) in Luxembourg and Net enrolment rate(%) in United Arab Emirates?
Your answer should be compact. 7.52. In the year 2011, what is the difference between the Net enrolment rate(%) in Mali and Net enrolment rate(%) in United Arab Emirates?
Your answer should be very brief. -19.71. In the year 2012, what is the difference between the Net enrolment rate(%) in Belize and Net enrolment rate(%) in Luxembourg?
Keep it short and to the point. 3.68. In the year 2012, what is the difference between the Net enrolment rate(%) in Belize and Net enrolment rate(%) in Mali?
Offer a terse response. 32.12. In the year 2012, what is the difference between the Net enrolment rate(%) in Belize and Net enrolment rate(%) in United Arab Emirates?
Make the answer very short. 6.32. In the year 2012, what is the difference between the Net enrolment rate(%) of Luxembourg and Net enrolment rate(%) of Mali?
Make the answer very short. 28.44. In the year 2012, what is the difference between the Net enrolment rate(%) of Luxembourg and Net enrolment rate(%) of United Arab Emirates?
Offer a very short reply. 2.64. In the year 2012, what is the difference between the Net enrolment rate(%) in Mali and Net enrolment rate(%) in United Arab Emirates?
Your response must be concise. -25.8. What is the ratio of the Net enrolment rate(%) in Mali in 2004 to that in 2005?
Ensure brevity in your answer.  0.94. What is the ratio of the Net enrolment rate(%) of United Arab Emirates in 2004 to that in 2005?
Keep it short and to the point. 0.98. What is the ratio of the Net enrolment rate(%) in Belize in 2004 to that in 2006?
Your response must be concise. 0.99. What is the ratio of the Net enrolment rate(%) of Luxembourg in 2004 to that in 2006?
Your answer should be compact. 0.99. What is the ratio of the Net enrolment rate(%) in Mali in 2004 to that in 2006?
Keep it short and to the point. 0.91. What is the ratio of the Net enrolment rate(%) of United Arab Emirates in 2004 to that in 2006?
Offer a terse response. 0.98. What is the ratio of the Net enrolment rate(%) of Luxembourg in 2004 to that in 2007?
Provide a short and direct response. 0.99. What is the ratio of the Net enrolment rate(%) of Mali in 2004 to that in 2007?
Offer a terse response. 0.87. What is the ratio of the Net enrolment rate(%) of United Arab Emirates in 2004 to that in 2007?
Provide a short and direct response. 0.95. What is the ratio of the Net enrolment rate(%) in Belize in 2004 to that in 2010?
Your answer should be very brief. 1. What is the ratio of the Net enrolment rate(%) of Luxembourg in 2004 to that in 2010?
Your answer should be very brief. 1.03. What is the ratio of the Net enrolment rate(%) in Mali in 2004 to that in 2010?
Your answer should be compact. 0.8. What is the ratio of the Net enrolment rate(%) of Belize in 2004 to that in 2011?
Provide a short and direct response. 1. What is the ratio of the Net enrolment rate(%) in Luxembourg in 2004 to that in 2011?
Provide a short and direct response. 1.03. What is the ratio of the Net enrolment rate(%) in Mali in 2004 to that in 2011?
Keep it short and to the point. 0.78. What is the ratio of the Net enrolment rate(%) in United Arab Emirates in 2004 to that in 2011?
Offer a terse response. 0.99. What is the ratio of the Net enrolment rate(%) of Belize in 2004 to that in 2012?
Give a very brief answer. 1. What is the ratio of the Net enrolment rate(%) in Luxembourg in 2004 to that in 2012?
Provide a succinct answer. 1.04. What is the ratio of the Net enrolment rate(%) in Mali in 2004 to that in 2012?
Give a very brief answer. 0.8. What is the ratio of the Net enrolment rate(%) in United Arab Emirates in 2004 to that in 2012?
Provide a short and direct response. 0.94. What is the ratio of the Net enrolment rate(%) of Luxembourg in 2005 to that in 2006?
Keep it short and to the point. 1. What is the ratio of the Net enrolment rate(%) of Mali in 2005 to that in 2006?
Keep it short and to the point. 0.97. What is the ratio of the Net enrolment rate(%) in Belize in 2005 to that in 2007?
Your answer should be very brief. 1. What is the ratio of the Net enrolment rate(%) of Luxembourg in 2005 to that in 2007?
Ensure brevity in your answer.  1. What is the ratio of the Net enrolment rate(%) of Mali in 2005 to that in 2007?
Keep it short and to the point. 0.93. What is the ratio of the Net enrolment rate(%) in United Arab Emirates in 2005 to that in 2007?
Give a very brief answer. 0.97. What is the ratio of the Net enrolment rate(%) in Belize in 2005 to that in 2010?
Your response must be concise. 1.01. What is the ratio of the Net enrolment rate(%) of Luxembourg in 2005 to that in 2010?
Your answer should be very brief. 1.04. What is the ratio of the Net enrolment rate(%) of Mali in 2005 to that in 2010?
Provide a succinct answer. 0.85. What is the ratio of the Net enrolment rate(%) of United Arab Emirates in 2005 to that in 2010?
Keep it short and to the point. 1.02. What is the ratio of the Net enrolment rate(%) of Belize in 2005 to that in 2011?
Offer a terse response. 1.01. What is the ratio of the Net enrolment rate(%) of Luxembourg in 2005 to that in 2011?
Your response must be concise. 1.04. What is the ratio of the Net enrolment rate(%) of Mali in 2005 to that in 2011?
Provide a succinct answer. 0.83. What is the ratio of the Net enrolment rate(%) of United Arab Emirates in 2005 to that in 2011?
Give a very brief answer. 1.01. What is the ratio of the Net enrolment rate(%) of Belize in 2005 to that in 2012?
Give a very brief answer. 1.01. What is the ratio of the Net enrolment rate(%) in Luxembourg in 2005 to that in 2012?
Your response must be concise. 1.04. What is the ratio of the Net enrolment rate(%) of Mali in 2005 to that in 2012?
Make the answer very short. 0.85. What is the ratio of the Net enrolment rate(%) in United Arab Emirates in 2005 to that in 2012?
Ensure brevity in your answer.  0.96. What is the ratio of the Net enrolment rate(%) of Belize in 2006 to that in 2007?
Your response must be concise. 1. What is the ratio of the Net enrolment rate(%) in Luxembourg in 2006 to that in 2007?
Offer a terse response. 1. What is the ratio of the Net enrolment rate(%) of Mali in 2006 to that in 2007?
Your answer should be compact. 0.96. What is the ratio of the Net enrolment rate(%) in United Arab Emirates in 2006 to that in 2007?
Make the answer very short. 0.97. What is the ratio of the Net enrolment rate(%) in Belize in 2006 to that in 2010?
Your answer should be compact. 1.01. What is the ratio of the Net enrolment rate(%) in Luxembourg in 2006 to that in 2010?
Offer a very short reply. 1.04. What is the ratio of the Net enrolment rate(%) in Mali in 2006 to that in 2010?
Give a very brief answer. 0.88. What is the ratio of the Net enrolment rate(%) of United Arab Emirates in 2006 to that in 2010?
Keep it short and to the point. 1.02. What is the ratio of the Net enrolment rate(%) of Belize in 2006 to that in 2011?
Give a very brief answer. 1.01. What is the ratio of the Net enrolment rate(%) of Luxembourg in 2006 to that in 2011?
Your answer should be compact. 1.04. What is the ratio of the Net enrolment rate(%) in Mali in 2006 to that in 2011?
Provide a short and direct response. 0.86. What is the ratio of the Net enrolment rate(%) of United Arab Emirates in 2006 to that in 2011?
Your answer should be very brief. 1.01. What is the ratio of the Net enrolment rate(%) of Belize in 2006 to that in 2012?
Provide a succinct answer. 1.01. What is the ratio of the Net enrolment rate(%) of Luxembourg in 2006 to that in 2012?
Offer a very short reply. 1.05. What is the ratio of the Net enrolment rate(%) in Mali in 2006 to that in 2012?
Provide a short and direct response. 0.88. What is the ratio of the Net enrolment rate(%) of United Arab Emirates in 2006 to that in 2012?
Ensure brevity in your answer.  0.96. What is the ratio of the Net enrolment rate(%) in Luxembourg in 2007 to that in 2010?
Your answer should be very brief. 1.04. What is the ratio of the Net enrolment rate(%) of Mali in 2007 to that in 2010?
Offer a very short reply. 0.91. What is the ratio of the Net enrolment rate(%) in United Arab Emirates in 2007 to that in 2010?
Your answer should be compact. 1.05. What is the ratio of the Net enrolment rate(%) in Belize in 2007 to that in 2011?
Offer a very short reply. 1.01. What is the ratio of the Net enrolment rate(%) of Luxembourg in 2007 to that in 2011?
Ensure brevity in your answer.  1.04. What is the ratio of the Net enrolment rate(%) of Mali in 2007 to that in 2011?
Keep it short and to the point. 0.89. What is the ratio of the Net enrolment rate(%) in United Arab Emirates in 2007 to that in 2011?
Make the answer very short. 1.04. What is the ratio of the Net enrolment rate(%) in Belize in 2007 to that in 2012?
Your answer should be very brief. 1.01. What is the ratio of the Net enrolment rate(%) in Luxembourg in 2007 to that in 2012?
Your answer should be very brief. 1.05. What is the ratio of the Net enrolment rate(%) in Mali in 2007 to that in 2012?
Offer a very short reply. 0.92. What is the ratio of the Net enrolment rate(%) in United Arab Emirates in 2007 to that in 2012?
Offer a terse response. 0.99. What is the ratio of the Net enrolment rate(%) of United Arab Emirates in 2010 to that in 2011?
Ensure brevity in your answer.  0.99. What is the ratio of the Net enrolment rate(%) of Luxembourg in 2010 to that in 2012?
Your answer should be compact. 1.01. What is the ratio of the Net enrolment rate(%) of United Arab Emirates in 2010 to that in 2012?
Your response must be concise. 0.94. What is the ratio of the Net enrolment rate(%) of Belize in 2011 to that in 2012?
Your response must be concise. 1. What is the ratio of the Net enrolment rate(%) in Luxembourg in 2011 to that in 2012?
Your answer should be very brief. 1. What is the ratio of the Net enrolment rate(%) of Mali in 2011 to that in 2012?
Make the answer very short. 1.03. What is the ratio of the Net enrolment rate(%) in United Arab Emirates in 2011 to that in 2012?
Provide a succinct answer. 0.95. What is the difference between the highest and the second highest Net enrolment rate(%) in Belize?
Keep it short and to the point. 0.34. What is the difference between the highest and the second highest Net enrolment rate(%) in Luxembourg?
Keep it short and to the point. 0.1. What is the difference between the highest and the second highest Net enrolment rate(%) in Mali?
Your answer should be very brief. 1.45. What is the difference between the highest and the second highest Net enrolment rate(%) in United Arab Emirates?
Give a very brief answer. 0.96. What is the difference between the highest and the lowest Net enrolment rate(%) in Belize?
Provide a short and direct response. 1.25. What is the difference between the highest and the lowest Net enrolment rate(%) in Luxembourg?
Offer a terse response. 4.29. What is the difference between the highest and the lowest Net enrolment rate(%) of Mali?
Your answer should be very brief. 14.43. What is the difference between the highest and the lowest Net enrolment rate(%) in United Arab Emirates?
Offer a very short reply. 5.5. 